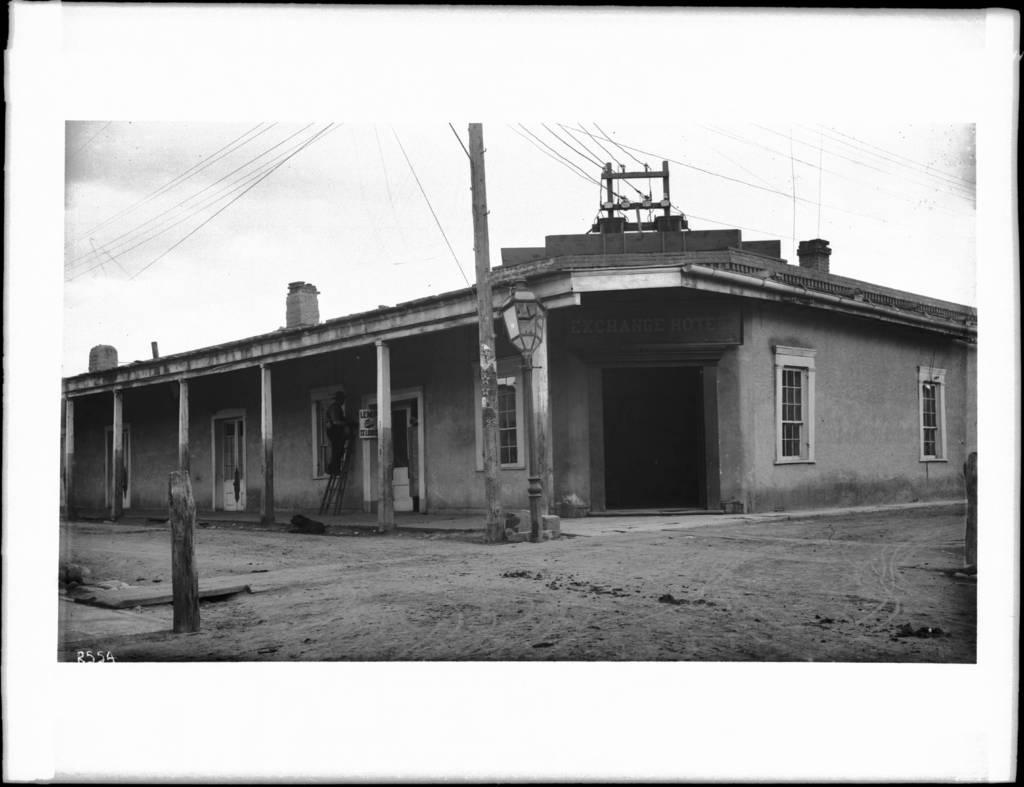What type of structure is visible in the image? There is a house in the image. What objects are in front of the house? There are poles in front of the house. What is the man in the image doing? The man is on a ladder in the image. What can be seen in the background of the image? There are cables visible in the background of the image. How long does it take for the man to dig a hole with a spade in the image? There is no spade present in the image, and the man is on a ladder, not digging a hole. 